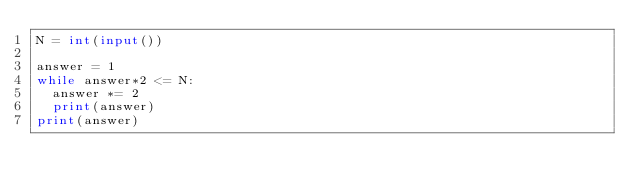<code> <loc_0><loc_0><loc_500><loc_500><_Python_>N = int(input())

answer = 1
while answer*2 <= N:
  answer *= 2
  print(answer)
print(answer)
</code> 